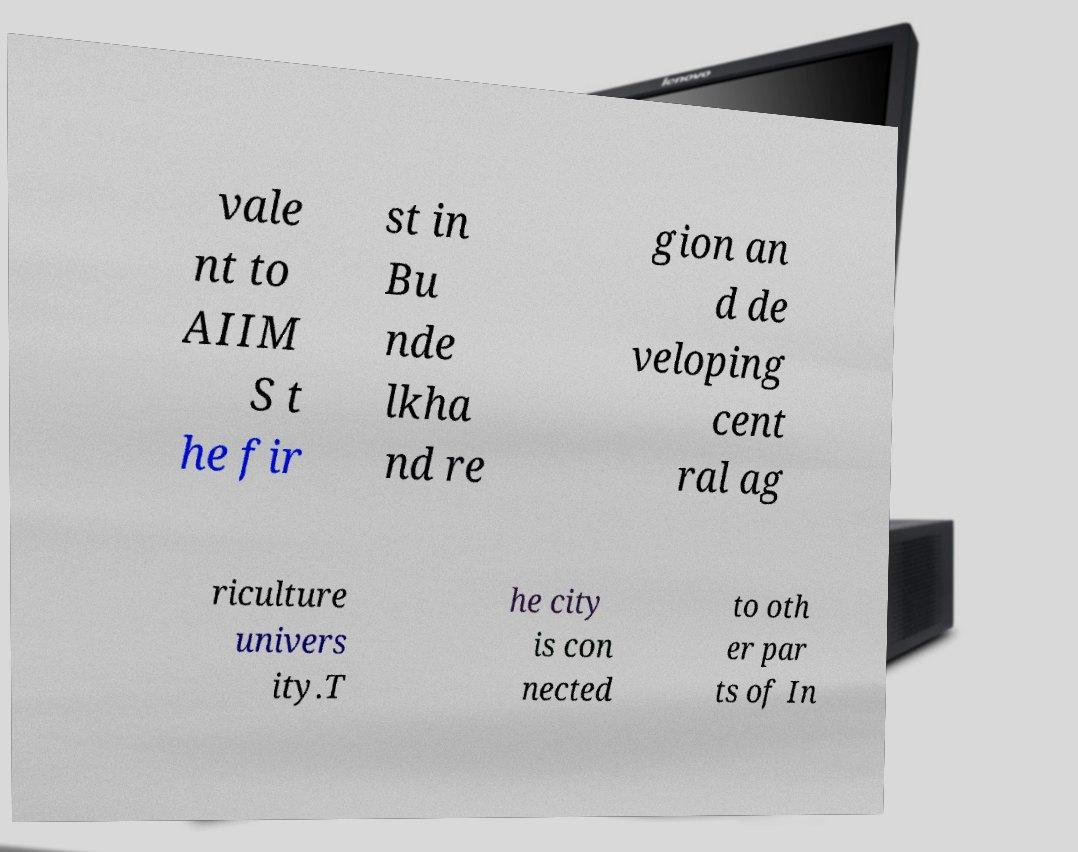Could you assist in decoding the text presented in this image and type it out clearly? vale nt to AIIM S t he fir st in Bu nde lkha nd re gion an d de veloping cent ral ag riculture univers ity.T he city is con nected to oth er par ts of In 